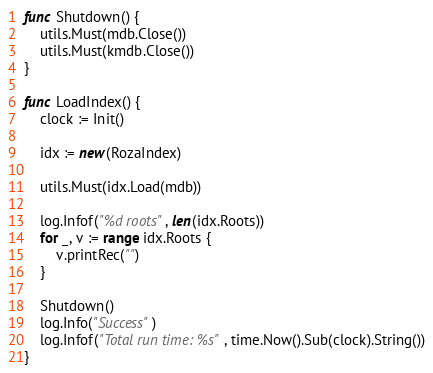<code> <loc_0><loc_0><loc_500><loc_500><_Go_>
func Shutdown() {
	utils.Must(mdb.Close())
	utils.Must(kmdb.Close())
}

func LoadIndex() {
	clock := Init()

	idx := new(RozaIndex)

	utils.Must(idx.Load(mdb))

	log.Infof("%d roots", len(idx.Roots))
	for _, v := range idx.Roots {
		v.printRec("")
	}

	Shutdown()
	log.Info("Success")
	log.Infof("Total run time: %s", time.Now().Sub(clock).String())
}
</code> 